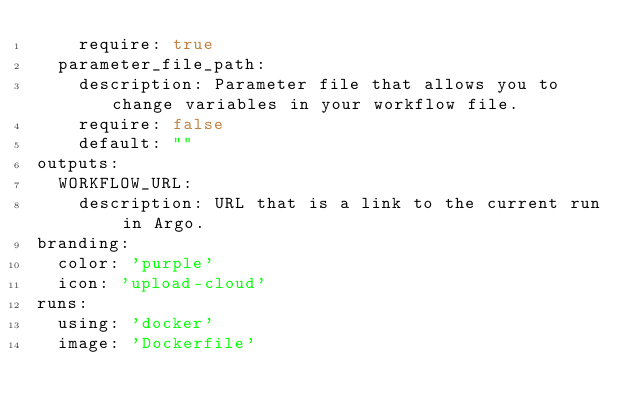<code> <loc_0><loc_0><loc_500><loc_500><_YAML_>    require: true
  parameter_file_path:
    description: Parameter file that allows you to change variables in your workflow file.
    require: false
    default: ""
outputs:
  WORKFLOW_URL:
    description: URL that is a link to the current run in Argo.
branding:
  color: 'purple'
  icon: 'upload-cloud'
runs:
  using: 'docker'
  image: 'Dockerfile'</code> 